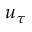<formula> <loc_0><loc_0><loc_500><loc_500>u _ { \tau }</formula> 